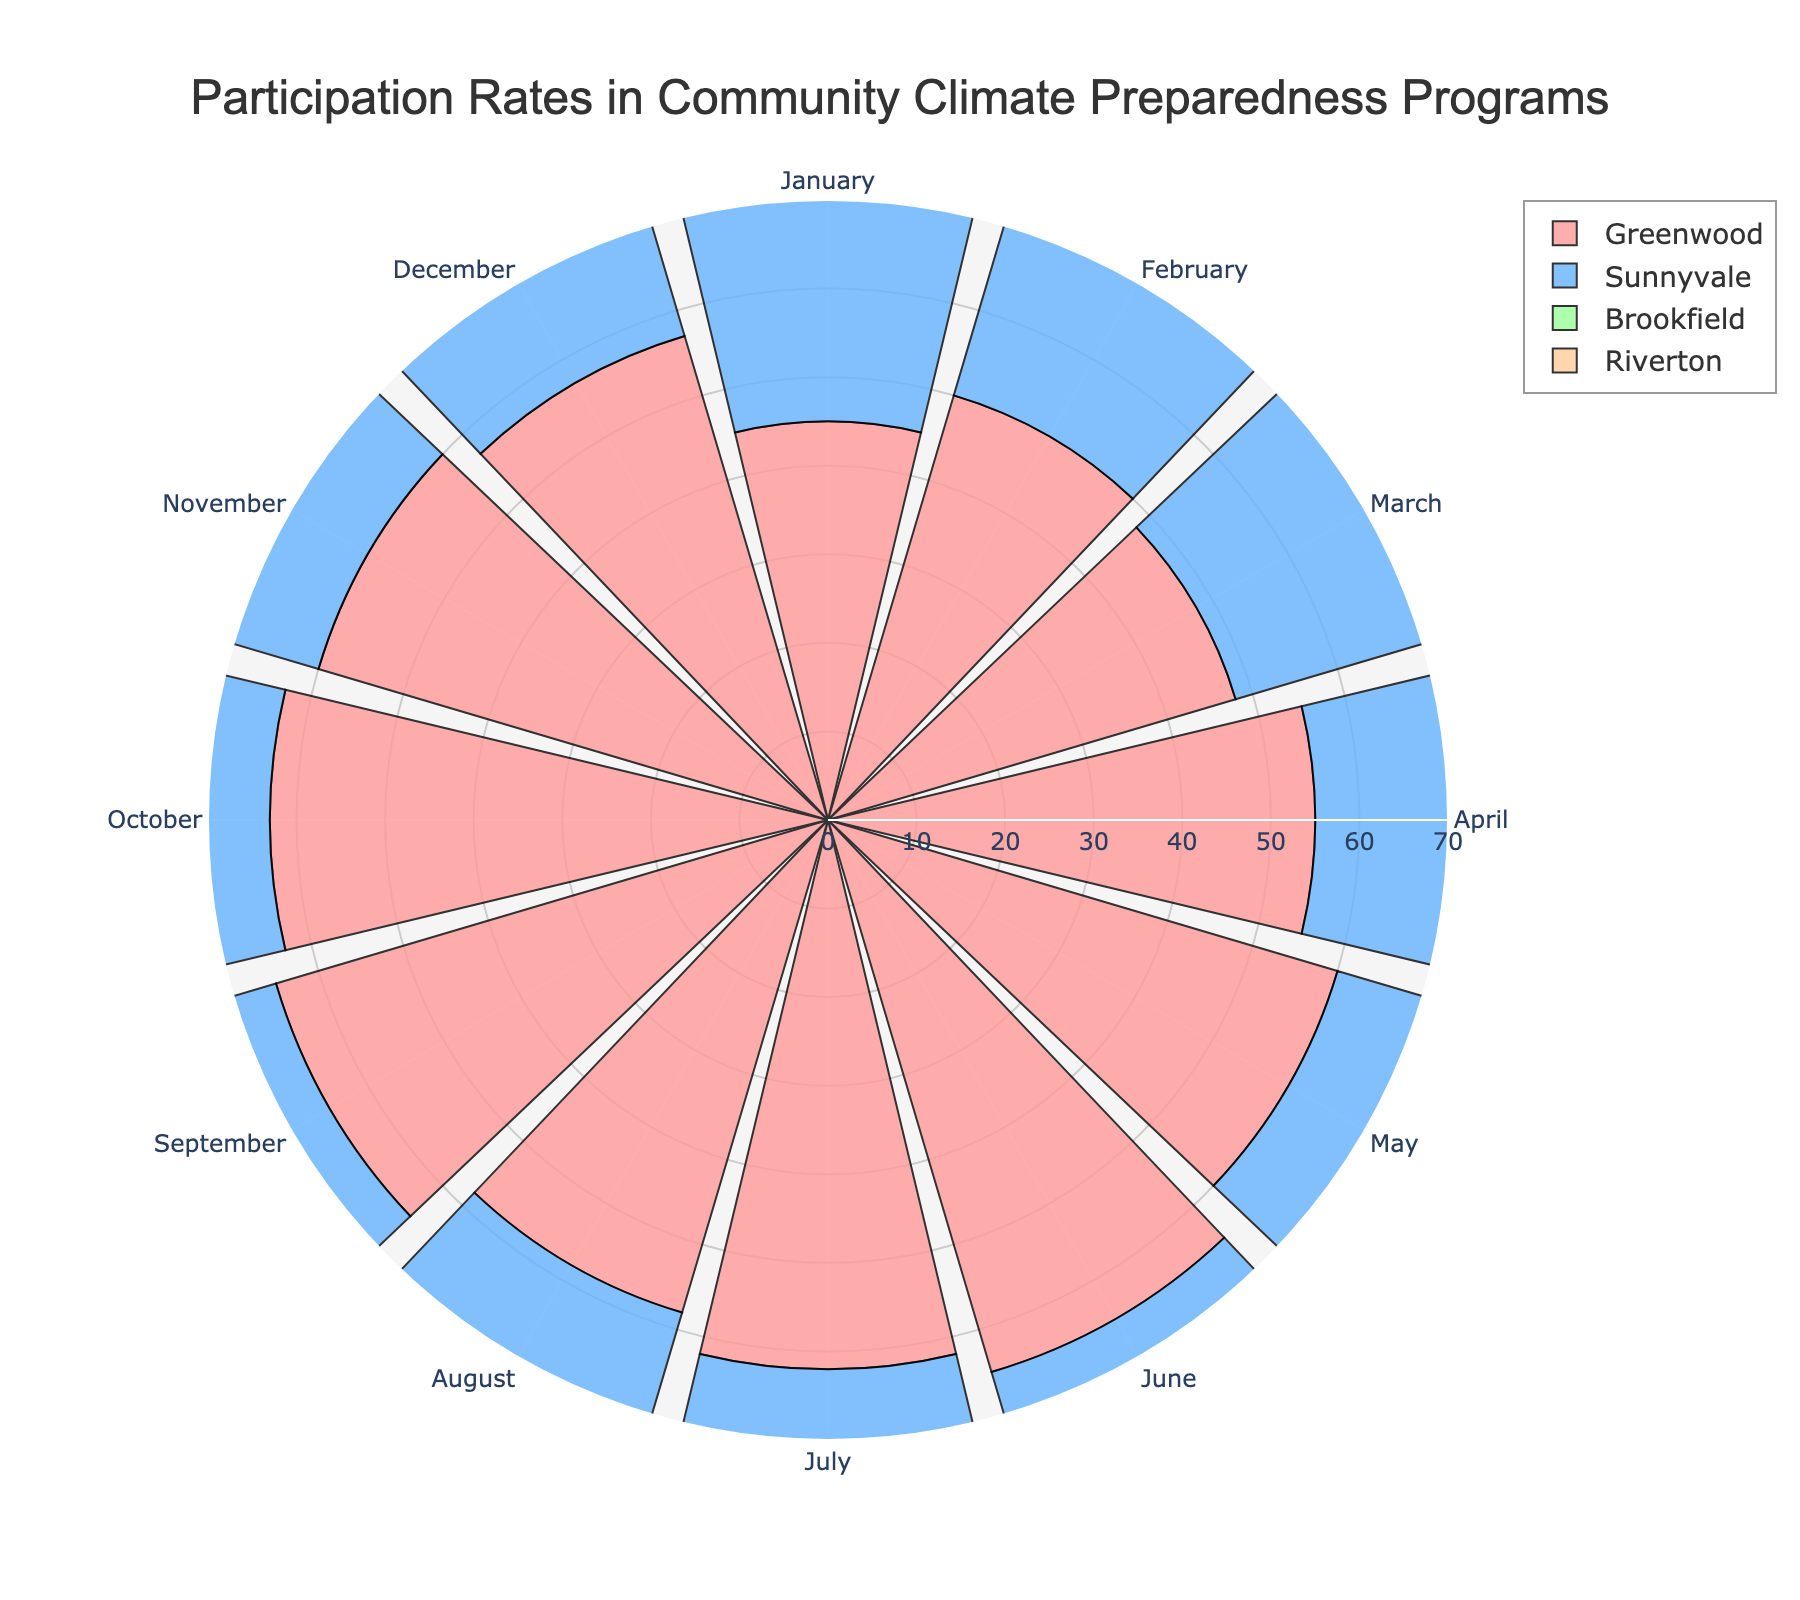What is the title of the figure? The title is usually found at the top of the chart. The title here reads "Participation Rates in Community Climate Preparedness Programs".
Answer: Participation Rates in Community Climate Preparedness Programs How many neighborhoods are shown in the chart? By looking at the different colored segments within each month on the polar bar chart, you can count that there are four unique neighborhoods represented.
Answer: Four Which neighborhood has the highest participation rate in the month of June? The height (or length) of the bars in June indicates participation rates for each neighborhood. Greenwood has the longest bar in June, indicating the highest rate at 65.
Answer: Greenwood In which month did Sunnyvale have its highest participation rate? Reviewing the lengths of Sunnyvale's bars across the months, we see that the longest bar for Sunnyvale is in June with a participation rate of 55.
Answer: June What is the participation rate range covered in the chart? The radial axis indicates the range of participation rates. It starts at 0 and goes up to 70.
Answer: 0 to 70 Comparing May and December, did Greenwood see an increase or decrease in participation rates? Observing the bars for Greenwood in May and December, Greenwood's participation rate decreased from 60 in May to 57 in December.
Answer: Decrease Which neighborhood had the highest participation rate on average throughout the year? Calculating the yearly average participation rates, Greenwood has the highest average at 57.08.
Answer: Greenwood 